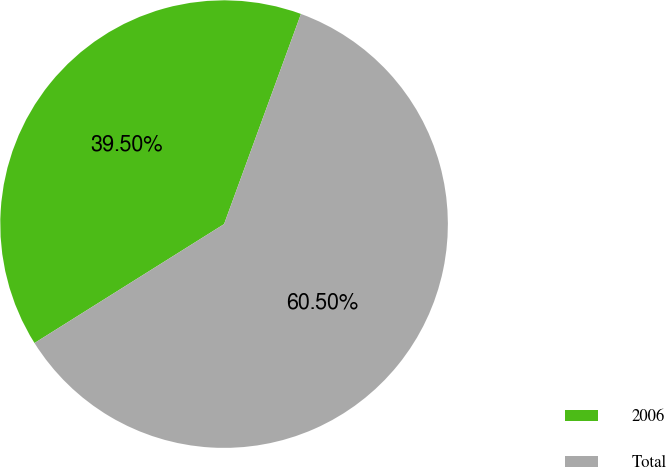Convert chart. <chart><loc_0><loc_0><loc_500><loc_500><pie_chart><fcel>2006<fcel>Total<nl><fcel>39.5%<fcel>60.5%<nl></chart> 